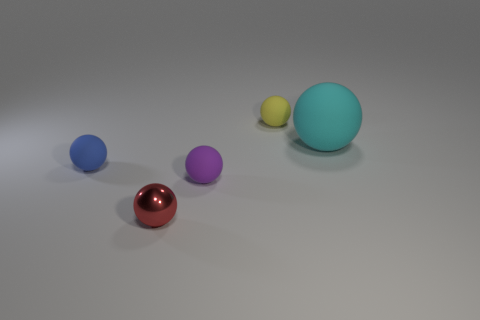Subtract all red balls. How many balls are left? 4 Subtract all metallic balls. How many balls are left? 4 Subtract all green balls. Subtract all purple cubes. How many balls are left? 5 Add 5 big rubber objects. How many objects exist? 10 Add 5 shiny objects. How many shiny objects are left? 6 Add 2 big cyan things. How many big cyan things exist? 3 Subtract 1 red balls. How many objects are left? 4 Subtract all red things. Subtract all large cyan spheres. How many objects are left? 3 